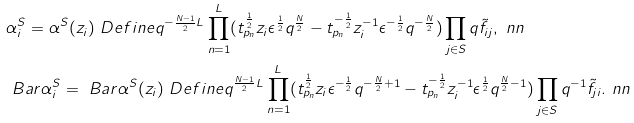Convert formula to latex. <formula><loc_0><loc_0><loc_500><loc_500>& \alpha ^ { S } _ { i } = \alpha ^ { S } ( z _ { i } ) \ D e f i n e q ^ { - \frac { N - 1 } { 2 } L } \prod _ { n = 1 } ^ { L } ( t _ { p _ { n } } ^ { \frac { 1 } { 2 } } z _ { i } \epsilon ^ { \frac { 1 } { 2 } } q ^ { \frac { N } { 2 } } - t _ { p _ { n } } ^ { - \frac { 1 } { 2 } } z _ { i } ^ { - 1 } \epsilon ^ { - \frac { 1 } { 2 } } q ^ { - \frac { N } { 2 } } ) \prod _ { j \in S } q \tilde { f } _ { i j } , \ n n \\ & \ B a r { \alpha } ^ { S } _ { i } = \ B a r { \alpha } ^ { S } ( z _ { i } ) \ D e f i n e q ^ { \frac { N - 1 } { 2 } L } \prod _ { n = 1 } ^ { L } ( t _ { p _ { n } } ^ { \frac { 1 } { 2 } } z _ { i } \epsilon ^ { - \frac { 1 } { 2 } } q ^ { - \frac { N } { 2 } + 1 } - t _ { p _ { n } } ^ { - \frac { 1 } { 2 } } z _ { i } ^ { - 1 } \epsilon ^ { \frac { 1 } { 2 } } q ^ { \frac { N } { 2 } - 1 } ) \prod _ { j \in S } q ^ { - 1 } \tilde { f } _ { j i } . \ n n</formula> 